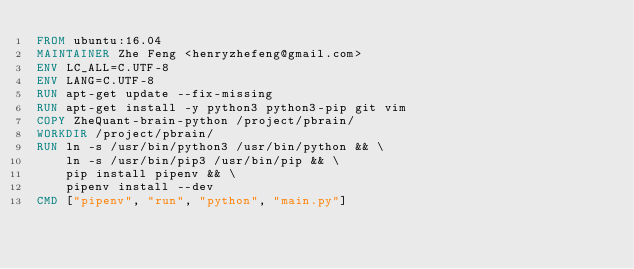Convert code to text. <code><loc_0><loc_0><loc_500><loc_500><_Dockerfile_>FROM ubuntu:16.04
MAINTAINER Zhe Feng <henryzhefeng@gmail.com>
ENV LC_ALL=C.UTF-8
ENV LANG=C.UTF-8
RUN apt-get update --fix-missing
RUN apt-get install -y python3 python3-pip git vim
COPY ZheQuant-brain-python /project/pbrain/
WORKDIR /project/pbrain/
RUN ln -s /usr/bin/python3 /usr/bin/python && \
    ln -s /usr/bin/pip3 /usr/bin/pip && \
    pip install pipenv && \
    pipenv install --dev
CMD ["pipenv", "run", "python", "main.py"]
</code> 